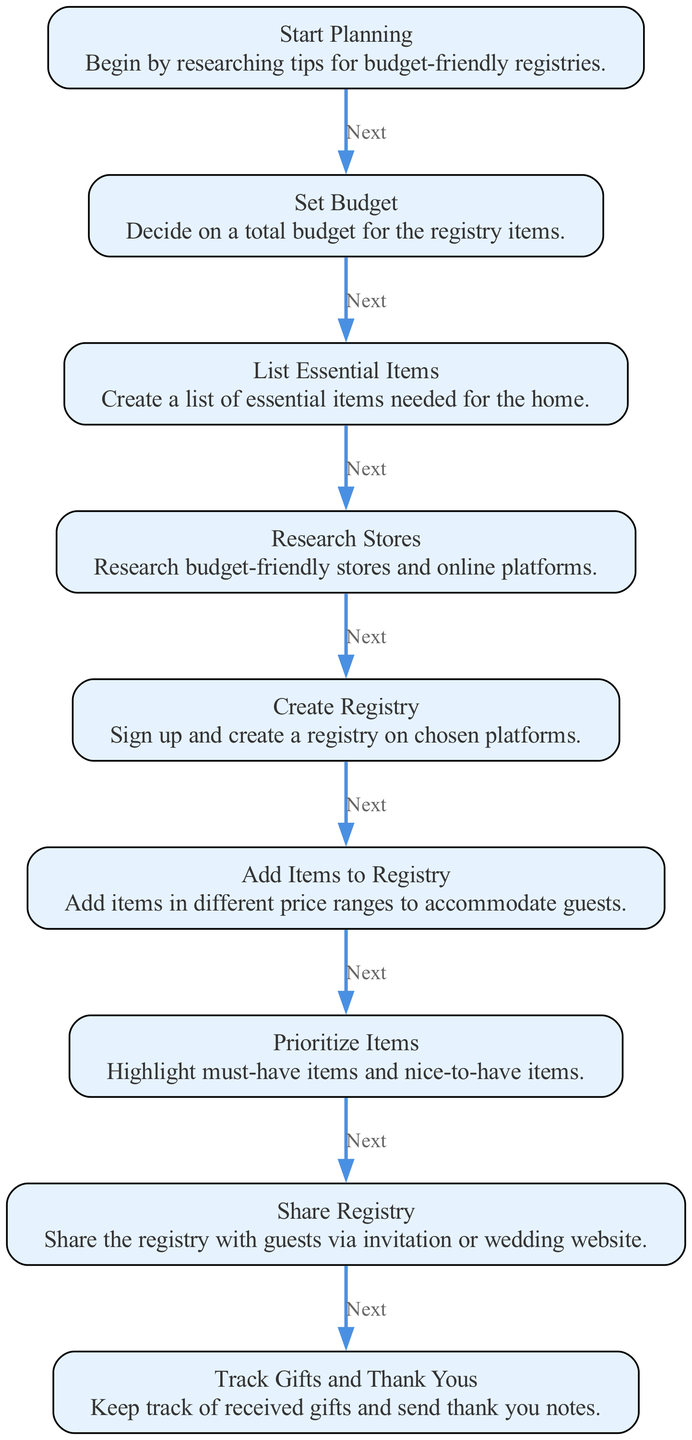What is the first step in the flowchart? The flowchart begins with the "Start Planning" node, which initiates the wedding registry creation process.
Answer: Start Planning How many nodes are there in the diagram? There are a total of 9 nodes represented in the flowchart, each corresponding to a step in the wedding registry creation process.
Answer: 9 What comes after the "Set Budget" step? Following the "Set Budget" step, the next step in the flowchart is "List Essential Items."
Answer: List Essential Items Which step includes highlighting items? The "Prioritize Items" step focuses on highlighting must-have and nice-to-have items in the registry.
Answer: Prioritize Items What is the last step in the flowchart? The final step in the flowchart is "Track Gifts and Thank Yous," which involves managing received gifts and sending thank-you notes.
Answer: Track Gifts and Thank Yous How many edges are there in the diagram? The diagram consists of 8 edges, each representing a connection from one step to the next in the flowchart.
Answer: 8 What action is suggested in the "Share Registry" step? The "Share Registry" step suggests sharing the registry with guests via invitation or wedding website, facilitating access to the registry.
Answer: Share the registry with guests Why is it important to set a budget before listing items? Setting a budget first helps to restrict excessive spending and ensure that the items listed are affordable within the defined financial limits.
Answer: To restrict spending What should be done after adding items to the registry? After adding items, the next action is to "Prioritize Items," where you categorize the items into must-haves and nice-to-haves.
Answer: Prioritize Items 